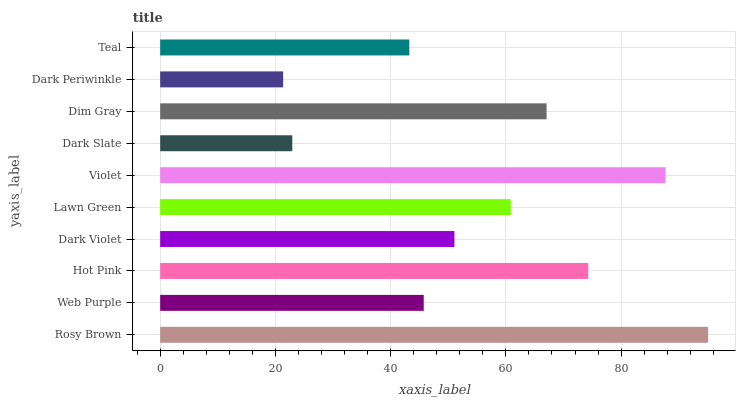Is Dark Periwinkle the minimum?
Answer yes or no. Yes. Is Rosy Brown the maximum?
Answer yes or no. Yes. Is Web Purple the minimum?
Answer yes or no. No. Is Web Purple the maximum?
Answer yes or no. No. Is Rosy Brown greater than Web Purple?
Answer yes or no. Yes. Is Web Purple less than Rosy Brown?
Answer yes or no. Yes. Is Web Purple greater than Rosy Brown?
Answer yes or no. No. Is Rosy Brown less than Web Purple?
Answer yes or no. No. Is Lawn Green the high median?
Answer yes or no. Yes. Is Dark Violet the low median?
Answer yes or no. Yes. Is Dim Gray the high median?
Answer yes or no. No. Is Teal the low median?
Answer yes or no. No. 